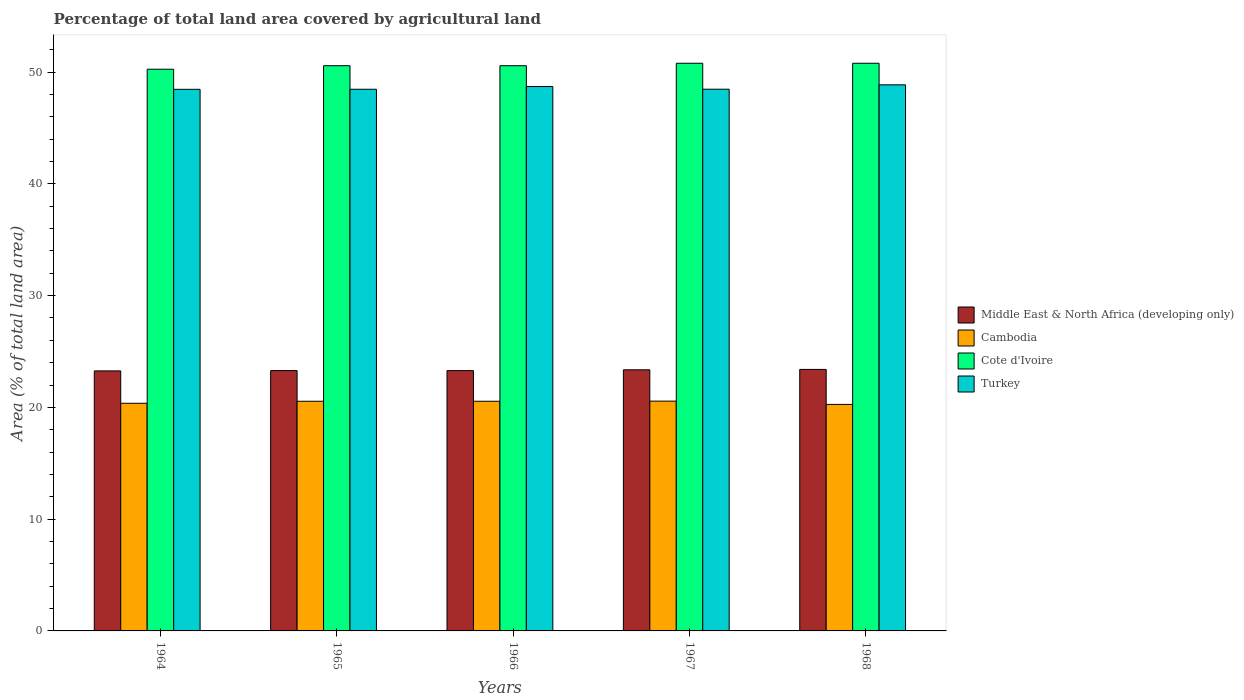How many groups of bars are there?
Ensure brevity in your answer.  5. Are the number of bars per tick equal to the number of legend labels?
Your answer should be compact. Yes. Are the number of bars on each tick of the X-axis equal?
Give a very brief answer. Yes. How many bars are there on the 2nd tick from the left?
Your answer should be very brief. 4. What is the label of the 1st group of bars from the left?
Give a very brief answer. 1964. What is the percentage of agricultural land in Cambodia in 1967?
Ensure brevity in your answer.  20.56. Across all years, what is the maximum percentage of agricultural land in Middle East & North Africa (developing only)?
Provide a succinct answer. 23.4. Across all years, what is the minimum percentage of agricultural land in Middle East & North Africa (developing only)?
Your answer should be compact. 23.26. In which year was the percentage of agricultural land in Cambodia maximum?
Ensure brevity in your answer.  1967. In which year was the percentage of agricultural land in Cambodia minimum?
Make the answer very short. 1968. What is the total percentage of agricultural land in Middle East & North Africa (developing only) in the graph?
Offer a very short reply. 116.6. What is the difference between the percentage of agricultural land in Cambodia in 1965 and that in 1968?
Ensure brevity in your answer.  0.28. What is the difference between the percentage of agricultural land in Turkey in 1965 and the percentage of agricultural land in Cote d'Ivoire in 1967?
Keep it short and to the point. -2.33. What is the average percentage of agricultural land in Middle East & North Africa (developing only) per year?
Offer a terse response. 23.32. In the year 1968, what is the difference between the percentage of agricultural land in Turkey and percentage of agricultural land in Cote d'Ivoire?
Ensure brevity in your answer.  -1.93. What is the ratio of the percentage of agricultural land in Cambodia in 1966 to that in 1968?
Keep it short and to the point. 1.01. Is the percentage of agricultural land in Cote d'Ivoire in 1966 less than that in 1967?
Provide a succinct answer. Yes. What is the difference between the highest and the second highest percentage of agricultural land in Cambodia?
Your response must be concise. 0.01. What is the difference between the highest and the lowest percentage of agricultural land in Turkey?
Your answer should be very brief. 0.4. Is the sum of the percentage of agricultural land in Turkey in 1964 and 1968 greater than the maximum percentage of agricultural land in Cambodia across all years?
Give a very brief answer. Yes. What does the 2nd bar from the left in 1966 represents?
Keep it short and to the point. Cambodia. What does the 2nd bar from the right in 1964 represents?
Give a very brief answer. Cote d'Ivoire. How many years are there in the graph?
Give a very brief answer. 5. Are the values on the major ticks of Y-axis written in scientific E-notation?
Offer a very short reply. No. Where does the legend appear in the graph?
Keep it short and to the point. Center right. How many legend labels are there?
Ensure brevity in your answer.  4. What is the title of the graph?
Your answer should be very brief. Percentage of total land area covered by agricultural land. What is the label or title of the Y-axis?
Your response must be concise. Area (% of total land area). What is the Area (% of total land area) of Middle East & North Africa (developing only) in 1964?
Your response must be concise. 23.26. What is the Area (% of total land area) in Cambodia in 1964?
Provide a succinct answer. 20.37. What is the Area (% of total land area) in Cote d'Ivoire in 1964?
Keep it short and to the point. 50.25. What is the Area (% of total land area) of Turkey in 1964?
Your response must be concise. 48.45. What is the Area (% of total land area) in Middle East & North Africa (developing only) in 1965?
Give a very brief answer. 23.29. What is the Area (% of total land area) in Cambodia in 1965?
Give a very brief answer. 20.55. What is the Area (% of total land area) of Cote d'Ivoire in 1965?
Provide a succinct answer. 50.57. What is the Area (% of total land area) of Turkey in 1965?
Offer a very short reply. 48.46. What is the Area (% of total land area) of Middle East & North Africa (developing only) in 1966?
Offer a terse response. 23.29. What is the Area (% of total land area) in Cambodia in 1966?
Keep it short and to the point. 20.55. What is the Area (% of total land area) of Cote d'Ivoire in 1966?
Your answer should be compact. 50.57. What is the Area (% of total land area) of Turkey in 1966?
Offer a very short reply. 48.7. What is the Area (% of total land area) in Middle East & North Africa (developing only) in 1967?
Your response must be concise. 23.36. What is the Area (% of total land area) of Cambodia in 1967?
Give a very brief answer. 20.56. What is the Area (% of total land area) in Cote d'Ivoire in 1967?
Keep it short and to the point. 50.79. What is the Area (% of total land area) in Turkey in 1967?
Offer a terse response. 48.46. What is the Area (% of total land area) of Middle East & North Africa (developing only) in 1968?
Ensure brevity in your answer.  23.4. What is the Area (% of total land area) of Cambodia in 1968?
Keep it short and to the point. 20.26. What is the Area (% of total land area) in Cote d'Ivoire in 1968?
Your answer should be very brief. 50.79. What is the Area (% of total land area) in Turkey in 1968?
Provide a succinct answer. 48.86. Across all years, what is the maximum Area (% of total land area) of Middle East & North Africa (developing only)?
Provide a short and direct response. 23.4. Across all years, what is the maximum Area (% of total land area) in Cambodia?
Keep it short and to the point. 20.56. Across all years, what is the maximum Area (% of total land area) in Cote d'Ivoire?
Your response must be concise. 50.79. Across all years, what is the maximum Area (% of total land area) of Turkey?
Your answer should be very brief. 48.86. Across all years, what is the minimum Area (% of total land area) in Middle East & North Africa (developing only)?
Give a very brief answer. 23.26. Across all years, what is the minimum Area (% of total land area) in Cambodia?
Your answer should be very brief. 20.26. Across all years, what is the minimum Area (% of total land area) of Cote d'Ivoire?
Your answer should be very brief. 50.25. Across all years, what is the minimum Area (% of total land area) of Turkey?
Offer a very short reply. 48.45. What is the total Area (% of total land area) in Middle East & North Africa (developing only) in the graph?
Provide a succinct answer. 116.6. What is the total Area (% of total land area) of Cambodia in the graph?
Provide a succinct answer. 102.28. What is the total Area (% of total land area) in Cote d'Ivoire in the graph?
Provide a succinct answer. 252.96. What is the total Area (% of total land area) in Turkey in the graph?
Make the answer very short. 242.94. What is the difference between the Area (% of total land area) of Middle East & North Africa (developing only) in 1964 and that in 1965?
Ensure brevity in your answer.  -0.03. What is the difference between the Area (% of total land area) in Cambodia in 1964 and that in 1965?
Make the answer very short. -0.18. What is the difference between the Area (% of total land area) of Cote d'Ivoire in 1964 and that in 1965?
Provide a short and direct response. -0.31. What is the difference between the Area (% of total land area) in Turkey in 1964 and that in 1965?
Offer a very short reply. -0.01. What is the difference between the Area (% of total land area) of Middle East & North Africa (developing only) in 1964 and that in 1966?
Your response must be concise. -0.03. What is the difference between the Area (% of total land area) in Cambodia in 1964 and that in 1966?
Your answer should be compact. -0.18. What is the difference between the Area (% of total land area) of Cote d'Ivoire in 1964 and that in 1966?
Give a very brief answer. -0.31. What is the difference between the Area (% of total land area) in Turkey in 1964 and that in 1966?
Your response must be concise. -0.25. What is the difference between the Area (% of total land area) in Middle East & North Africa (developing only) in 1964 and that in 1967?
Offer a terse response. -0.1. What is the difference between the Area (% of total land area) of Cambodia in 1964 and that in 1967?
Provide a succinct answer. -0.19. What is the difference between the Area (% of total land area) in Cote d'Ivoire in 1964 and that in 1967?
Provide a succinct answer. -0.53. What is the difference between the Area (% of total land area) in Turkey in 1964 and that in 1967?
Your response must be concise. -0.01. What is the difference between the Area (% of total land area) of Middle East & North Africa (developing only) in 1964 and that in 1968?
Give a very brief answer. -0.13. What is the difference between the Area (% of total land area) in Cambodia in 1964 and that in 1968?
Give a very brief answer. 0.1. What is the difference between the Area (% of total land area) of Cote d'Ivoire in 1964 and that in 1968?
Offer a very short reply. -0.53. What is the difference between the Area (% of total land area) of Turkey in 1964 and that in 1968?
Your answer should be compact. -0.4. What is the difference between the Area (% of total land area) in Middle East & North Africa (developing only) in 1965 and that in 1966?
Provide a short and direct response. 0. What is the difference between the Area (% of total land area) of Turkey in 1965 and that in 1966?
Your response must be concise. -0.24. What is the difference between the Area (% of total land area) in Middle East & North Africa (developing only) in 1965 and that in 1967?
Give a very brief answer. -0.07. What is the difference between the Area (% of total land area) of Cambodia in 1965 and that in 1967?
Offer a very short reply. -0.01. What is the difference between the Area (% of total land area) of Cote d'Ivoire in 1965 and that in 1967?
Ensure brevity in your answer.  -0.22. What is the difference between the Area (% of total land area) in Turkey in 1965 and that in 1967?
Offer a terse response. -0.01. What is the difference between the Area (% of total land area) of Middle East & North Africa (developing only) in 1965 and that in 1968?
Your response must be concise. -0.11. What is the difference between the Area (% of total land area) in Cambodia in 1965 and that in 1968?
Offer a very short reply. 0.28. What is the difference between the Area (% of total land area) in Cote d'Ivoire in 1965 and that in 1968?
Provide a succinct answer. -0.22. What is the difference between the Area (% of total land area) in Turkey in 1965 and that in 1968?
Give a very brief answer. -0.4. What is the difference between the Area (% of total land area) of Middle East & North Africa (developing only) in 1966 and that in 1967?
Give a very brief answer. -0.07. What is the difference between the Area (% of total land area) in Cambodia in 1966 and that in 1967?
Provide a succinct answer. -0.01. What is the difference between the Area (% of total land area) of Cote d'Ivoire in 1966 and that in 1967?
Provide a succinct answer. -0.22. What is the difference between the Area (% of total land area) in Turkey in 1966 and that in 1967?
Give a very brief answer. 0.24. What is the difference between the Area (% of total land area) in Middle East & North Africa (developing only) in 1966 and that in 1968?
Your response must be concise. -0.11. What is the difference between the Area (% of total land area) of Cambodia in 1966 and that in 1968?
Your answer should be very brief. 0.28. What is the difference between the Area (% of total land area) of Cote d'Ivoire in 1966 and that in 1968?
Make the answer very short. -0.22. What is the difference between the Area (% of total land area) of Turkey in 1966 and that in 1968?
Your answer should be compact. -0.15. What is the difference between the Area (% of total land area) in Middle East & North Africa (developing only) in 1967 and that in 1968?
Your response must be concise. -0.04. What is the difference between the Area (% of total land area) in Cambodia in 1967 and that in 1968?
Give a very brief answer. 0.29. What is the difference between the Area (% of total land area) in Cote d'Ivoire in 1967 and that in 1968?
Make the answer very short. 0. What is the difference between the Area (% of total land area) in Turkey in 1967 and that in 1968?
Offer a very short reply. -0.39. What is the difference between the Area (% of total land area) of Middle East & North Africa (developing only) in 1964 and the Area (% of total land area) of Cambodia in 1965?
Keep it short and to the point. 2.72. What is the difference between the Area (% of total land area) in Middle East & North Africa (developing only) in 1964 and the Area (% of total land area) in Cote d'Ivoire in 1965?
Your answer should be compact. -27.3. What is the difference between the Area (% of total land area) of Middle East & North Africa (developing only) in 1964 and the Area (% of total land area) of Turkey in 1965?
Offer a very short reply. -25.2. What is the difference between the Area (% of total land area) in Cambodia in 1964 and the Area (% of total land area) in Cote d'Ivoire in 1965?
Offer a very short reply. -30.2. What is the difference between the Area (% of total land area) of Cambodia in 1964 and the Area (% of total land area) of Turkey in 1965?
Keep it short and to the point. -28.09. What is the difference between the Area (% of total land area) in Cote d'Ivoire in 1964 and the Area (% of total land area) in Turkey in 1965?
Provide a short and direct response. 1.79. What is the difference between the Area (% of total land area) in Middle East & North Africa (developing only) in 1964 and the Area (% of total land area) in Cambodia in 1966?
Provide a succinct answer. 2.72. What is the difference between the Area (% of total land area) of Middle East & North Africa (developing only) in 1964 and the Area (% of total land area) of Cote d'Ivoire in 1966?
Your answer should be compact. -27.3. What is the difference between the Area (% of total land area) of Middle East & North Africa (developing only) in 1964 and the Area (% of total land area) of Turkey in 1966?
Your response must be concise. -25.44. What is the difference between the Area (% of total land area) of Cambodia in 1964 and the Area (% of total land area) of Cote d'Ivoire in 1966?
Your answer should be compact. -30.2. What is the difference between the Area (% of total land area) of Cambodia in 1964 and the Area (% of total land area) of Turkey in 1966?
Offer a terse response. -28.34. What is the difference between the Area (% of total land area) of Cote d'Ivoire in 1964 and the Area (% of total land area) of Turkey in 1966?
Your answer should be very brief. 1.55. What is the difference between the Area (% of total land area) in Middle East & North Africa (developing only) in 1964 and the Area (% of total land area) in Cambodia in 1967?
Ensure brevity in your answer.  2.7. What is the difference between the Area (% of total land area) in Middle East & North Africa (developing only) in 1964 and the Area (% of total land area) in Cote d'Ivoire in 1967?
Offer a very short reply. -27.52. What is the difference between the Area (% of total land area) of Middle East & North Africa (developing only) in 1964 and the Area (% of total land area) of Turkey in 1967?
Make the answer very short. -25.2. What is the difference between the Area (% of total land area) in Cambodia in 1964 and the Area (% of total land area) in Cote d'Ivoire in 1967?
Give a very brief answer. -30.42. What is the difference between the Area (% of total land area) in Cambodia in 1964 and the Area (% of total land area) in Turkey in 1967?
Keep it short and to the point. -28.1. What is the difference between the Area (% of total land area) in Cote d'Ivoire in 1964 and the Area (% of total land area) in Turkey in 1967?
Provide a succinct answer. 1.79. What is the difference between the Area (% of total land area) of Middle East & North Africa (developing only) in 1964 and the Area (% of total land area) of Cambodia in 1968?
Make the answer very short. 3. What is the difference between the Area (% of total land area) in Middle East & North Africa (developing only) in 1964 and the Area (% of total land area) in Cote d'Ivoire in 1968?
Keep it short and to the point. -27.52. What is the difference between the Area (% of total land area) of Middle East & North Africa (developing only) in 1964 and the Area (% of total land area) of Turkey in 1968?
Ensure brevity in your answer.  -25.59. What is the difference between the Area (% of total land area) in Cambodia in 1964 and the Area (% of total land area) in Cote d'Ivoire in 1968?
Make the answer very short. -30.42. What is the difference between the Area (% of total land area) in Cambodia in 1964 and the Area (% of total land area) in Turkey in 1968?
Your answer should be compact. -28.49. What is the difference between the Area (% of total land area) in Cote d'Ivoire in 1964 and the Area (% of total land area) in Turkey in 1968?
Offer a terse response. 1.4. What is the difference between the Area (% of total land area) in Middle East & North Africa (developing only) in 1965 and the Area (% of total land area) in Cambodia in 1966?
Your answer should be very brief. 2.74. What is the difference between the Area (% of total land area) in Middle East & North Africa (developing only) in 1965 and the Area (% of total land area) in Cote d'Ivoire in 1966?
Provide a short and direct response. -27.27. What is the difference between the Area (% of total land area) of Middle East & North Africa (developing only) in 1965 and the Area (% of total land area) of Turkey in 1966?
Give a very brief answer. -25.41. What is the difference between the Area (% of total land area) of Cambodia in 1965 and the Area (% of total land area) of Cote d'Ivoire in 1966?
Make the answer very short. -30.02. What is the difference between the Area (% of total land area) in Cambodia in 1965 and the Area (% of total land area) in Turkey in 1966?
Give a very brief answer. -28.16. What is the difference between the Area (% of total land area) of Cote d'Ivoire in 1965 and the Area (% of total land area) of Turkey in 1966?
Give a very brief answer. 1.86. What is the difference between the Area (% of total land area) of Middle East & North Africa (developing only) in 1965 and the Area (% of total land area) of Cambodia in 1967?
Your response must be concise. 2.73. What is the difference between the Area (% of total land area) in Middle East & North Africa (developing only) in 1965 and the Area (% of total land area) in Cote d'Ivoire in 1967?
Provide a succinct answer. -27.49. What is the difference between the Area (% of total land area) of Middle East & North Africa (developing only) in 1965 and the Area (% of total land area) of Turkey in 1967?
Offer a terse response. -25.17. What is the difference between the Area (% of total land area) in Cambodia in 1965 and the Area (% of total land area) in Cote d'Ivoire in 1967?
Ensure brevity in your answer.  -30.24. What is the difference between the Area (% of total land area) of Cambodia in 1965 and the Area (% of total land area) of Turkey in 1967?
Provide a short and direct response. -27.92. What is the difference between the Area (% of total land area) in Cote d'Ivoire in 1965 and the Area (% of total land area) in Turkey in 1967?
Provide a succinct answer. 2.1. What is the difference between the Area (% of total land area) of Middle East & North Africa (developing only) in 1965 and the Area (% of total land area) of Cambodia in 1968?
Your answer should be compact. 3.03. What is the difference between the Area (% of total land area) of Middle East & North Africa (developing only) in 1965 and the Area (% of total land area) of Cote d'Ivoire in 1968?
Provide a short and direct response. -27.49. What is the difference between the Area (% of total land area) in Middle East & North Africa (developing only) in 1965 and the Area (% of total land area) in Turkey in 1968?
Ensure brevity in your answer.  -25.56. What is the difference between the Area (% of total land area) in Cambodia in 1965 and the Area (% of total land area) in Cote d'Ivoire in 1968?
Offer a very short reply. -30.24. What is the difference between the Area (% of total land area) of Cambodia in 1965 and the Area (% of total land area) of Turkey in 1968?
Give a very brief answer. -28.31. What is the difference between the Area (% of total land area) of Cote d'Ivoire in 1965 and the Area (% of total land area) of Turkey in 1968?
Ensure brevity in your answer.  1.71. What is the difference between the Area (% of total land area) in Middle East & North Africa (developing only) in 1966 and the Area (% of total land area) in Cambodia in 1967?
Ensure brevity in your answer.  2.73. What is the difference between the Area (% of total land area) in Middle East & North Africa (developing only) in 1966 and the Area (% of total land area) in Cote d'Ivoire in 1967?
Offer a very short reply. -27.5. What is the difference between the Area (% of total land area) in Middle East & North Africa (developing only) in 1966 and the Area (% of total land area) in Turkey in 1967?
Your response must be concise. -25.18. What is the difference between the Area (% of total land area) of Cambodia in 1966 and the Area (% of total land area) of Cote d'Ivoire in 1967?
Your response must be concise. -30.24. What is the difference between the Area (% of total land area) of Cambodia in 1966 and the Area (% of total land area) of Turkey in 1967?
Ensure brevity in your answer.  -27.92. What is the difference between the Area (% of total land area) in Cote d'Ivoire in 1966 and the Area (% of total land area) in Turkey in 1967?
Offer a very short reply. 2.1. What is the difference between the Area (% of total land area) of Middle East & North Africa (developing only) in 1966 and the Area (% of total land area) of Cambodia in 1968?
Your answer should be compact. 3.02. What is the difference between the Area (% of total land area) of Middle East & North Africa (developing only) in 1966 and the Area (% of total land area) of Cote d'Ivoire in 1968?
Give a very brief answer. -27.5. What is the difference between the Area (% of total land area) in Middle East & North Africa (developing only) in 1966 and the Area (% of total land area) in Turkey in 1968?
Your answer should be compact. -25.57. What is the difference between the Area (% of total land area) of Cambodia in 1966 and the Area (% of total land area) of Cote d'Ivoire in 1968?
Provide a short and direct response. -30.24. What is the difference between the Area (% of total land area) of Cambodia in 1966 and the Area (% of total land area) of Turkey in 1968?
Offer a very short reply. -28.31. What is the difference between the Area (% of total land area) of Cote d'Ivoire in 1966 and the Area (% of total land area) of Turkey in 1968?
Your answer should be very brief. 1.71. What is the difference between the Area (% of total land area) in Middle East & North Africa (developing only) in 1967 and the Area (% of total land area) in Cambodia in 1968?
Provide a succinct answer. 3.1. What is the difference between the Area (% of total land area) of Middle East & North Africa (developing only) in 1967 and the Area (% of total land area) of Cote d'Ivoire in 1968?
Keep it short and to the point. -27.42. What is the difference between the Area (% of total land area) in Middle East & North Africa (developing only) in 1967 and the Area (% of total land area) in Turkey in 1968?
Offer a terse response. -25.49. What is the difference between the Area (% of total land area) of Cambodia in 1967 and the Area (% of total land area) of Cote d'Ivoire in 1968?
Your answer should be very brief. -30.23. What is the difference between the Area (% of total land area) of Cambodia in 1967 and the Area (% of total land area) of Turkey in 1968?
Offer a terse response. -28.3. What is the difference between the Area (% of total land area) of Cote d'Ivoire in 1967 and the Area (% of total land area) of Turkey in 1968?
Your answer should be very brief. 1.93. What is the average Area (% of total land area) of Middle East & North Africa (developing only) per year?
Your response must be concise. 23.32. What is the average Area (% of total land area) of Cambodia per year?
Offer a very short reply. 20.46. What is the average Area (% of total land area) of Cote d'Ivoire per year?
Keep it short and to the point. 50.59. What is the average Area (% of total land area) in Turkey per year?
Ensure brevity in your answer.  48.59. In the year 1964, what is the difference between the Area (% of total land area) in Middle East & North Africa (developing only) and Area (% of total land area) in Cambodia?
Your answer should be very brief. 2.9. In the year 1964, what is the difference between the Area (% of total land area) of Middle East & North Africa (developing only) and Area (% of total land area) of Cote d'Ivoire?
Offer a very short reply. -26.99. In the year 1964, what is the difference between the Area (% of total land area) of Middle East & North Africa (developing only) and Area (% of total land area) of Turkey?
Give a very brief answer. -25.19. In the year 1964, what is the difference between the Area (% of total land area) in Cambodia and Area (% of total land area) in Cote d'Ivoire?
Your answer should be very brief. -29.89. In the year 1964, what is the difference between the Area (% of total land area) in Cambodia and Area (% of total land area) in Turkey?
Provide a succinct answer. -28.09. In the year 1964, what is the difference between the Area (% of total land area) in Cote d'Ivoire and Area (% of total land area) in Turkey?
Make the answer very short. 1.8. In the year 1965, what is the difference between the Area (% of total land area) in Middle East & North Africa (developing only) and Area (% of total land area) in Cambodia?
Ensure brevity in your answer.  2.74. In the year 1965, what is the difference between the Area (% of total land area) of Middle East & North Africa (developing only) and Area (% of total land area) of Cote d'Ivoire?
Offer a terse response. -27.27. In the year 1965, what is the difference between the Area (% of total land area) of Middle East & North Africa (developing only) and Area (% of total land area) of Turkey?
Keep it short and to the point. -25.17. In the year 1965, what is the difference between the Area (% of total land area) in Cambodia and Area (% of total land area) in Cote d'Ivoire?
Ensure brevity in your answer.  -30.02. In the year 1965, what is the difference between the Area (% of total land area) in Cambodia and Area (% of total land area) in Turkey?
Your answer should be compact. -27.91. In the year 1965, what is the difference between the Area (% of total land area) of Cote d'Ivoire and Area (% of total land area) of Turkey?
Your response must be concise. 2.11. In the year 1966, what is the difference between the Area (% of total land area) in Middle East & North Africa (developing only) and Area (% of total land area) in Cambodia?
Give a very brief answer. 2.74. In the year 1966, what is the difference between the Area (% of total land area) of Middle East & North Africa (developing only) and Area (% of total land area) of Cote d'Ivoire?
Your answer should be compact. -27.28. In the year 1966, what is the difference between the Area (% of total land area) of Middle East & North Africa (developing only) and Area (% of total land area) of Turkey?
Keep it short and to the point. -25.42. In the year 1966, what is the difference between the Area (% of total land area) of Cambodia and Area (% of total land area) of Cote d'Ivoire?
Your response must be concise. -30.02. In the year 1966, what is the difference between the Area (% of total land area) of Cambodia and Area (% of total land area) of Turkey?
Your response must be concise. -28.16. In the year 1966, what is the difference between the Area (% of total land area) of Cote d'Ivoire and Area (% of total land area) of Turkey?
Offer a terse response. 1.86. In the year 1967, what is the difference between the Area (% of total land area) in Middle East & North Africa (developing only) and Area (% of total land area) in Cambodia?
Give a very brief answer. 2.8. In the year 1967, what is the difference between the Area (% of total land area) in Middle East & North Africa (developing only) and Area (% of total land area) in Cote d'Ivoire?
Give a very brief answer. -27.42. In the year 1967, what is the difference between the Area (% of total land area) of Middle East & North Africa (developing only) and Area (% of total land area) of Turkey?
Your response must be concise. -25.1. In the year 1967, what is the difference between the Area (% of total land area) in Cambodia and Area (% of total land area) in Cote d'Ivoire?
Provide a succinct answer. -30.23. In the year 1967, what is the difference between the Area (% of total land area) in Cambodia and Area (% of total land area) in Turkey?
Make the answer very short. -27.91. In the year 1967, what is the difference between the Area (% of total land area) in Cote d'Ivoire and Area (% of total land area) in Turkey?
Provide a succinct answer. 2.32. In the year 1968, what is the difference between the Area (% of total land area) of Middle East & North Africa (developing only) and Area (% of total land area) of Cambodia?
Provide a succinct answer. 3.13. In the year 1968, what is the difference between the Area (% of total land area) in Middle East & North Africa (developing only) and Area (% of total land area) in Cote d'Ivoire?
Offer a terse response. -27.39. In the year 1968, what is the difference between the Area (% of total land area) of Middle East & North Africa (developing only) and Area (% of total land area) of Turkey?
Make the answer very short. -25.46. In the year 1968, what is the difference between the Area (% of total land area) in Cambodia and Area (% of total land area) in Cote d'Ivoire?
Provide a succinct answer. -30.52. In the year 1968, what is the difference between the Area (% of total land area) of Cambodia and Area (% of total land area) of Turkey?
Make the answer very short. -28.59. In the year 1968, what is the difference between the Area (% of total land area) in Cote d'Ivoire and Area (% of total land area) in Turkey?
Make the answer very short. 1.93. What is the ratio of the Area (% of total land area) in Middle East & North Africa (developing only) in 1964 to that in 1965?
Your answer should be compact. 1. What is the ratio of the Area (% of total land area) in Cambodia in 1964 to that in 1965?
Give a very brief answer. 0.99. What is the ratio of the Area (% of total land area) in Turkey in 1964 to that in 1965?
Your response must be concise. 1. What is the ratio of the Area (% of total land area) of Cambodia in 1964 to that in 1966?
Offer a terse response. 0.99. What is the ratio of the Area (% of total land area) in Cote d'Ivoire in 1964 to that in 1966?
Ensure brevity in your answer.  0.99. What is the ratio of the Area (% of total land area) in Middle East & North Africa (developing only) in 1964 to that in 1967?
Provide a succinct answer. 1. What is the ratio of the Area (% of total land area) in Cambodia in 1964 to that in 1967?
Offer a very short reply. 0.99. What is the ratio of the Area (% of total land area) of Turkey in 1964 to that in 1967?
Offer a very short reply. 1. What is the ratio of the Area (% of total land area) of Cote d'Ivoire in 1964 to that in 1968?
Your answer should be compact. 0.99. What is the ratio of the Area (% of total land area) in Middle East & North Africa (developing only) in 1965 to that in 1966?
Keep it short and to the point. 1. What is the ratio of the Area (% of total land area) of Cambodia in 1965 to that in 1966?
Offer a terse response. 1. What is the ratio of the Area (% of total land area) in Turkey in 1965 to that in 1966?
Keep it short and to the point. 0.99. What is the ratio of the Area (% of total land area) in Middle East & North Africa (developing only) in 1965 to that in 1967?
Your answer should be compact. 1. What is the ratio of the Area (% of total land area) in Cambodia in 1965 to that in 1967?
Offer a very short reply. 1. What is the ratio of the Area (% of total land area) in Cote d'Ivoire in 1965 to that in 1967?
Make the answer very short. 1. What is the ratio of the Area (% of total land area) in Cote d'Ivoire in 1965 to that in 1968?
Your response must be concise. 1. What is the ratio of the Area (% of total land area) of Turkey in 1965 to that in 1968?
Provide a short and direct response. 0.99. What is the ratio of the Area (% of total land area) of Turkey in 1966 to that in 1967?
Your answer should be very brief. 1. What is the ratio of the Area (% of total land area) of Middle East & North Africa (developing only) in 1966 to that in 1968?
Provide a succinct answer. 1. What is the ratio of the Area (% of total land area) in Cote d'Ivoire in 1966 to that in 1968?
Provide a succinct answer. 1. What is the ratio of the Area (% of total land area) of Turkey in 1966 to that in 1968?
Keep it short and to the point. 1. What is the ratio of the Area (% of total land area) in Cambodia in 1967 to that in 1968?
Offer a terse response. 1.01. What is the ratio of the Area (% of total land area) in Cote d'Ivoire in 1967 to that in 1968?
Offer a terse response. 1. What is the ratio of the Area (% of total land area) of Turkey in 1967 to that in 1968?
Keep it short and to the point. 0.99. What is the difference between the highest and the second highest Area (% of total land area) of Middle East & North Africa (developing only)?
Give a very brief answer. 0.04. What is the difference between the highest and the second highest Area (% of total land area) of Cambodia?
Provide a succinct answer. 0.01. What is the difference between the highest and the second highest Area (% of total land area) of Cote d'Ivoire?
Your answer should be very brief. 0. What is the difference between the highest and the second highest Area (% of total land area) of Turkey?
Your response must be concise. 0.15. What is the difference between the highest and the lowest Area (% of total land area) of Middle East & North Africa (developing only)?
Ensure brevity in your answer.  0.13. What is the difference between the highest and the lowest Area (% of total land area) of Cambodia?
Give a very brief answer. 0.29. What is the difference between the highest and the lowest Area (% of total land area) in Cote d'Ivoire?
Provide a succinct answer. 0.53. What is the difference between the highest and the lowest Area (% of total land area) in Turkey?
Keep it short and to the point. 0.4. 